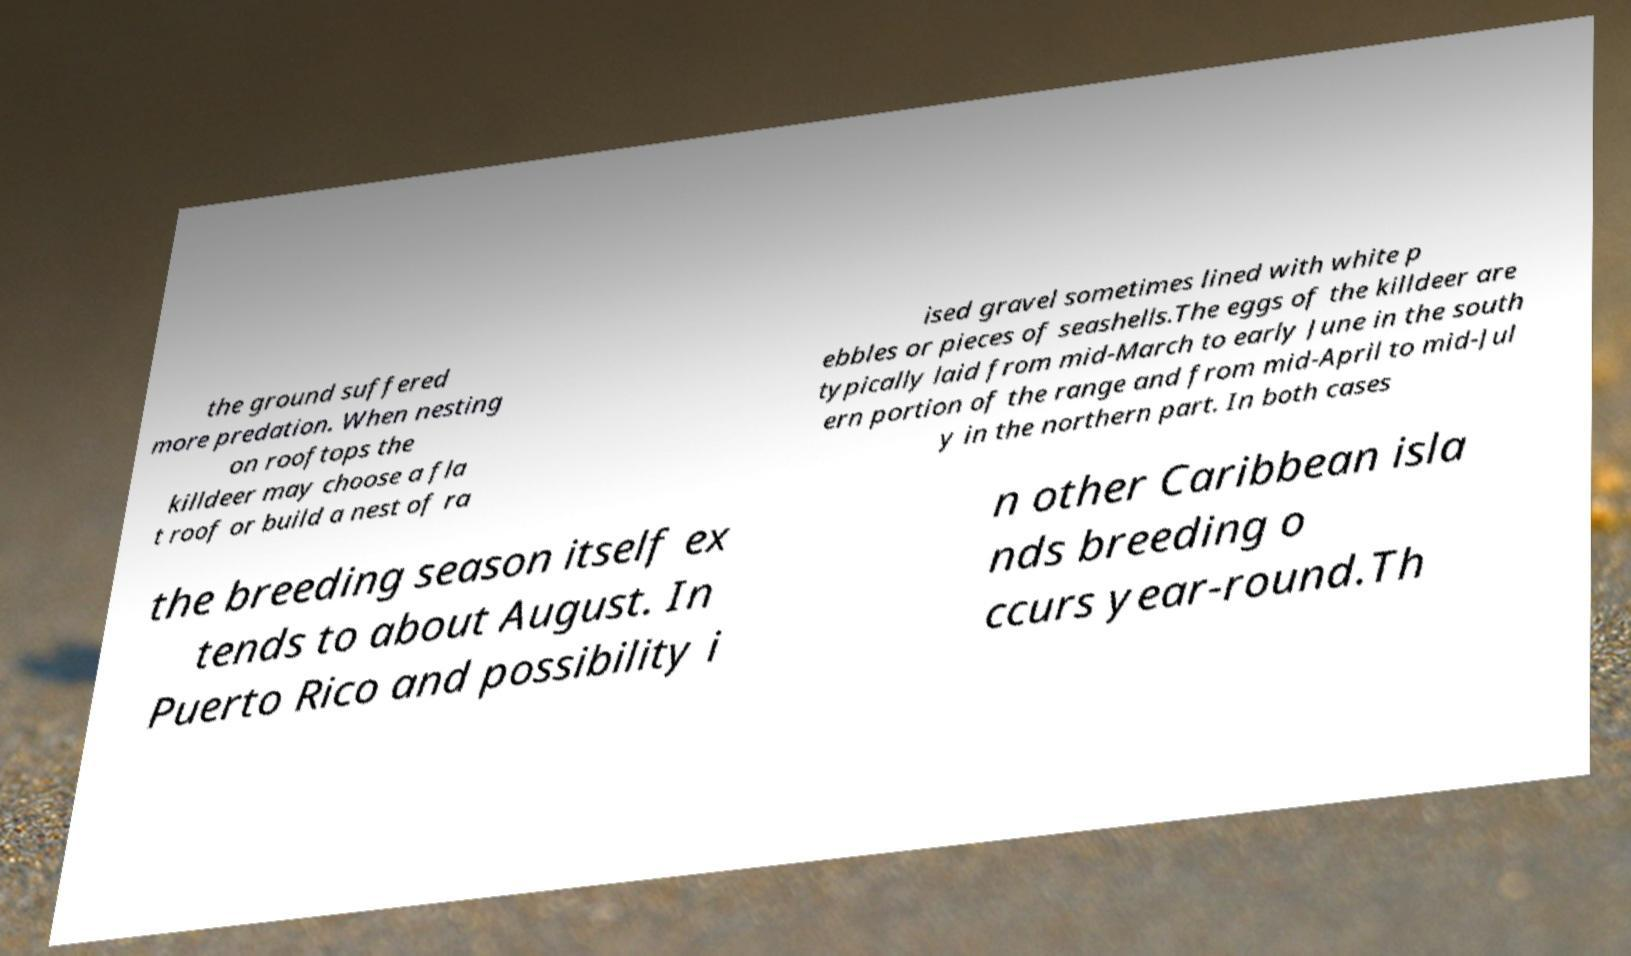Could you assist in decoding the text presented in this image and type it out clearly? the ground suffered more predation. When nesting on rooftops the killdeer may choose a fla t roof or build a nest of ra ised gravel sometimes lined with white p ebbles or pieces of seashells.The eggs of the killdeer are typically laid from mid-March to early June in the south ern portion of the range and from mid-April to mid-Jul y in the northern part. In both cases the breeding season itself ex tends to about August. In Puerto Rico and possibility i n other Caribbean isla nds breeding o ccurs year-round.Th 